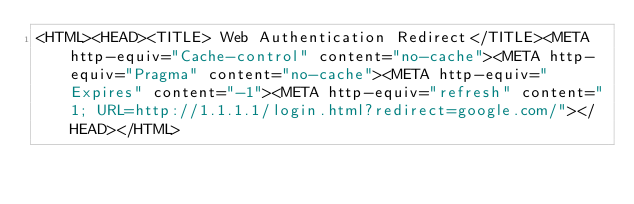Convert code to text. <code><loc_0><loc_0><loc_500><loc_500><_HTML_><HTML><HEAD><TITLE> Web Authentication Redirect</TITLE><META http-equiv="Cache-control" content="no-cache"><META http-equiv="Pragma" content="no-cache"><META http-equiv="Expires" content="-1"><META http-equiv="refresh" content="1; URL=http://1.1.1.1/login.html?redirect=google.com/"></HEAD></HTML>
</code> 